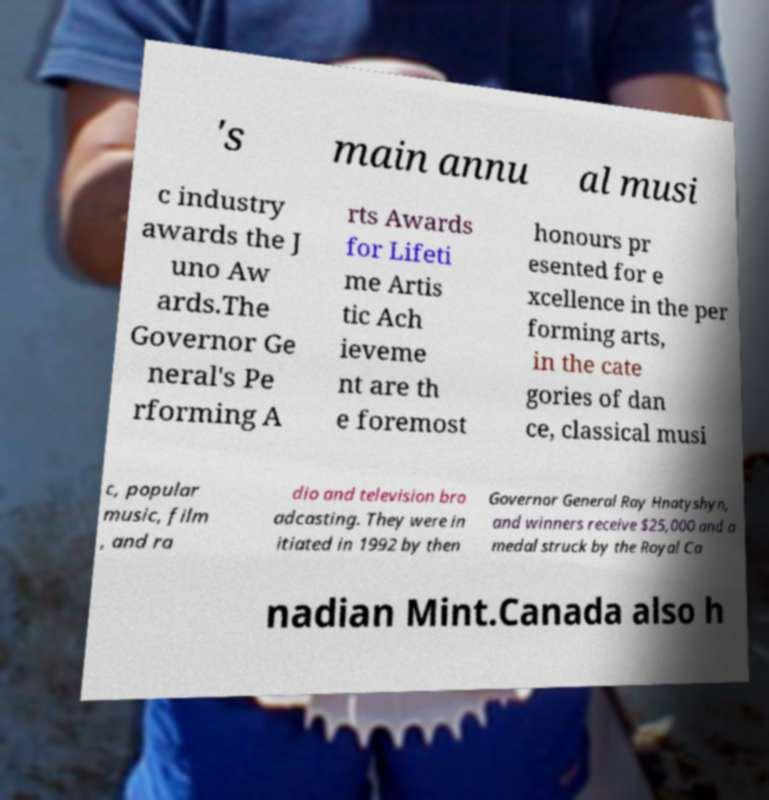What messages or text are displayed in this image? I need them in a readable, typed format. 's main annu al musi c industry awards the J uno Aw ards.The Governor Ge neral's Pe rforming A rts Awards for Lifeti me Artis tic Ach ieveme nt are th e foremost honours pr esented for e xcellence in the per forming arts, in the cate gories of dan ce, classical musi c, popular music, film , and ra dio and television bro adcasting. They were in itiated in 1992 by then Governor General Ray Hnatyshyn, and winners receive $25,000 and a medal struck by the Royal Ca nadian Mint.Canada also h 